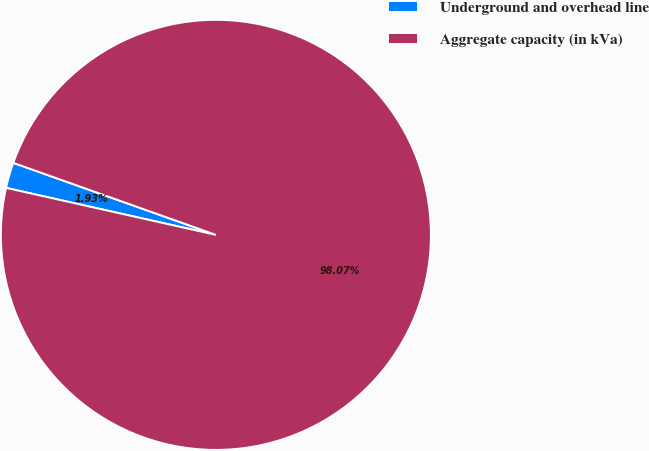Convert chart. <chart><loc_0><loc_0><loc_500><loc_500><pie_chart><fcel>Underground and overhead line<fcel>Aggregate capacity (in kVa)<nl><fcel>1.93%<fcel>98.07%<nl></chart> 